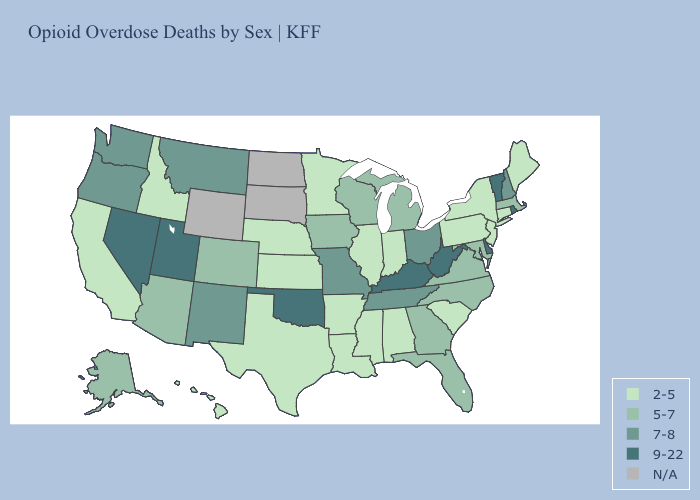What is the value of Alabama?
Keep it brief. 2-5. Which states have the lowest value in the South?
Quick response, please. Alabama, Arkansas, Louisiana, Mississippi, South Carolina, Texas. Does the map have missing data?
Quick response, please. Yes. Does Oklahoma have the highest value in the South?
Be succinct. Yes. Does the first symbol in the legend represent the smallest category?
Give a very brief answer. Yes. What is the highest value in states that border Iowa?
Concise answer only. 7-8. Does the first symbol in the legend represent the smallest category?
Give a very brief answer. Yes. Name the states that have a value in the range 5-7?
Be succinct. Alaska, Arizona, Colorado, Florida, Georgia, Iowa, Maryland, Massachusetts, Michigan, North Carolina, Virginia, Wisconsin. Name the states that have a value in the range 5-7?
Short answer required. Alaska, Arizona, Colorado, Florida, Georgia, Iowa, Maryland, Massachusetts, Michigan, North Carolina, Virginia, Wisconsin. Name the states that have a value in the range 5-7?
Quick response, please. Alaska, Arizona, Colorado, Florida, Georgia, Iowa, Maryland, Massachusetts, Michigan, North Carolina, Virginia, Wisconsin. What is the highest value in the West ?
Be succinct. 9-22. What is the value of Tennessee?
Short answer required. 7-8. What is the lowest value in states that border Arizona?
Keep it brief. 2-5. Does Delaware have the highest value in the USA?
Short answer required. Yes. Name the states that have a value in the range 9-22?
Concise answer only. Delaware, Kentucky, Nevada, Oklahoma, Rhode Island, Utah, Vermont, West Virginia. 